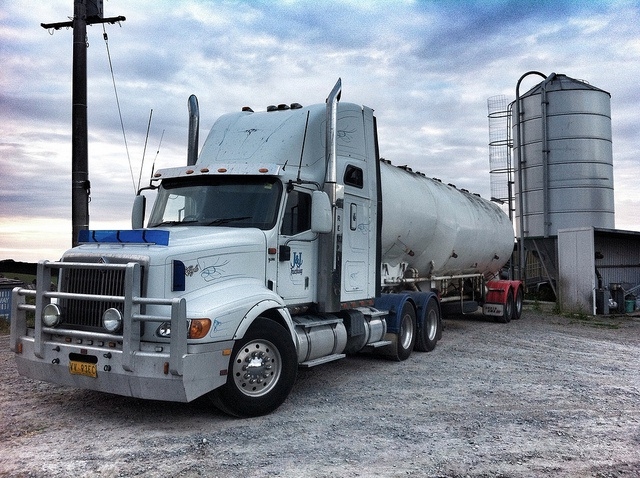Describe the objects in this image and their specific colors. I can see a truck in lavender, black, gray, and darkgray tones in this image. 